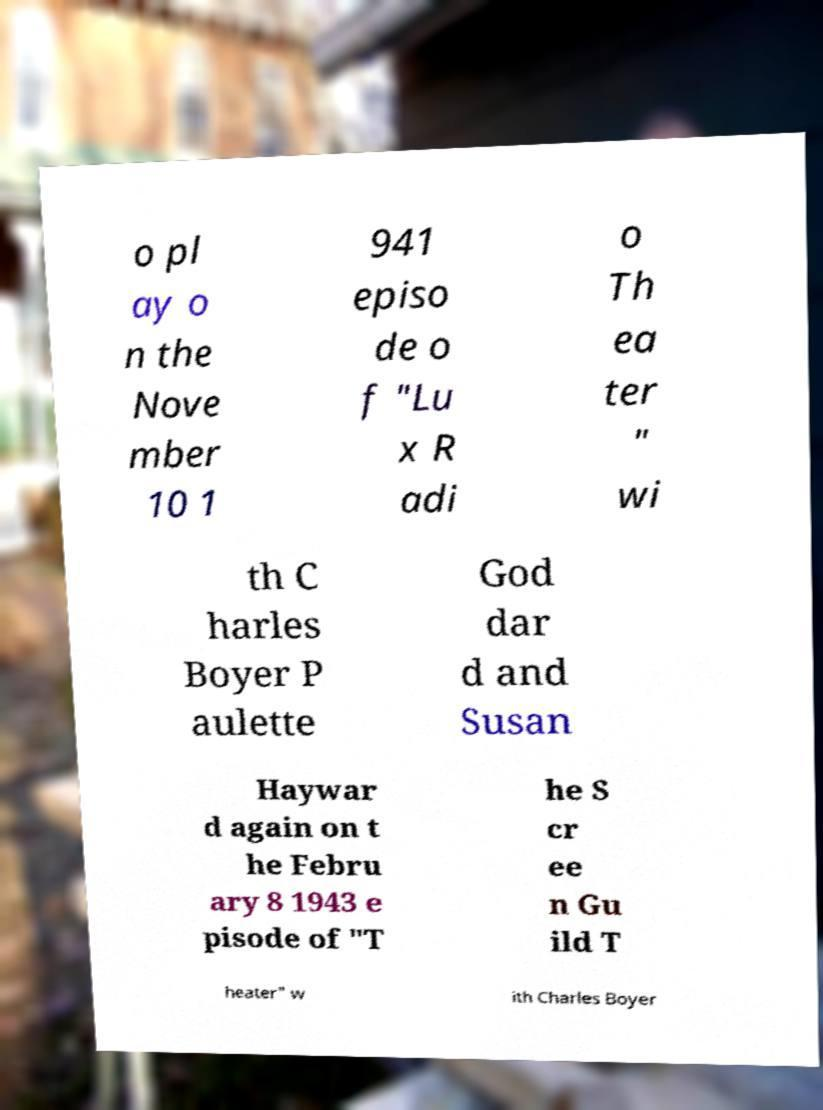Please identify and transcribe the text found in this image. o pl ay o n the Nove mber 10 1 941 episo de o f "Lu x R adi o Th ea ter " wi th C harles Boyer P aulette God dar d and Susan Haywar d again on t he Febru ary 8 1943 e pisode of "T he S cr ee n Gu ild T heater" w ith Charles Boyer 